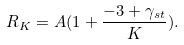Convert formula to latex. <formula><loc_0><loc_0><loc_500><loc_500>R _ { K } = A ( 1 + \frac { - 3 + \gamma _ { s t } } { K } ) .</formula> 